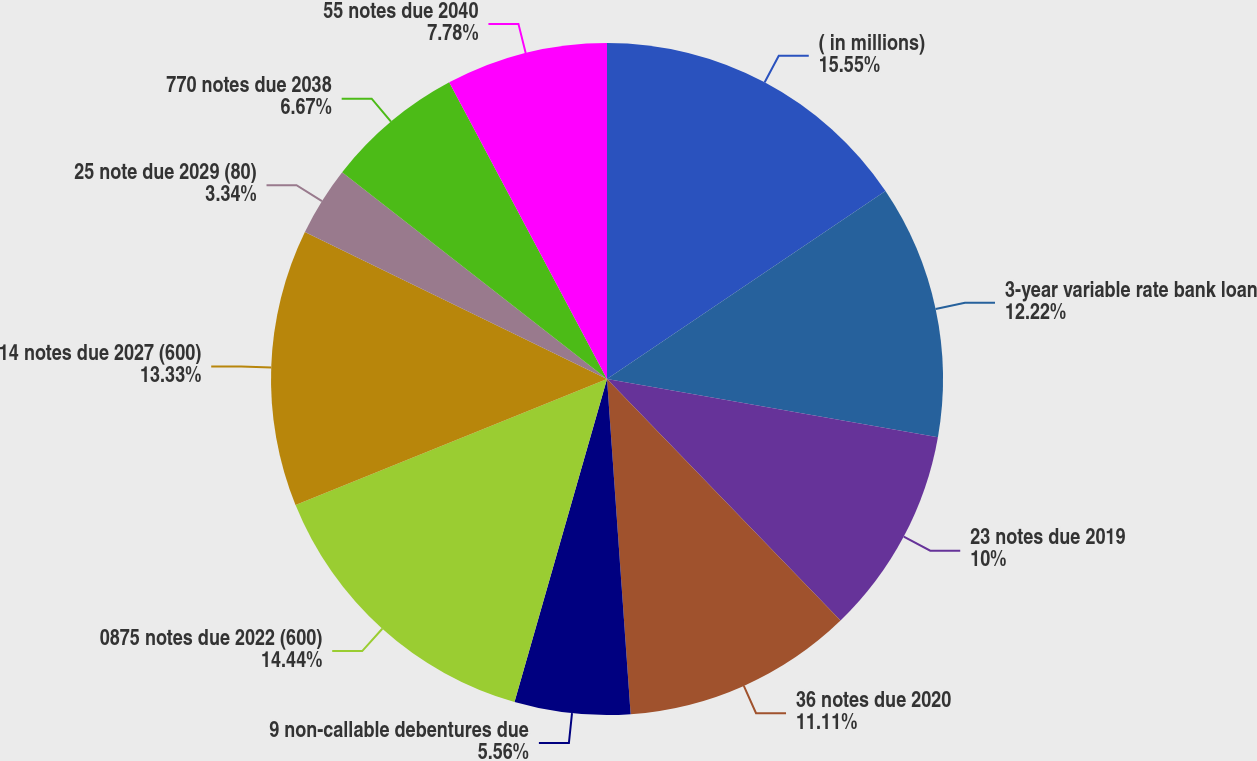<chart> <loc_0><loc_0><loc_500><loc_500><pie_chart><fcel>( in millions)<fcel>3-year variable rate bank loan<fcel>23 notes due 2019<fcel>36 notes due 2020<fcel>9 non-callable debentures due<fcel>0875 notes due 2022 (600)<fcel>14 notes due 2027 (600)<fcel>25 note due 2029 (80)<fcel>770 notes due 2038<fcel>55 notes due 2040<nl><fcel>15.55%<fcel>12.22%<fcel>10.0%<fcel>11.11%<fcel>5.56%<fcel>14.44%<fcel>13.33%<fcel>3.34%<fcel>6.67%<fcel>7.78%<nl></chart> 